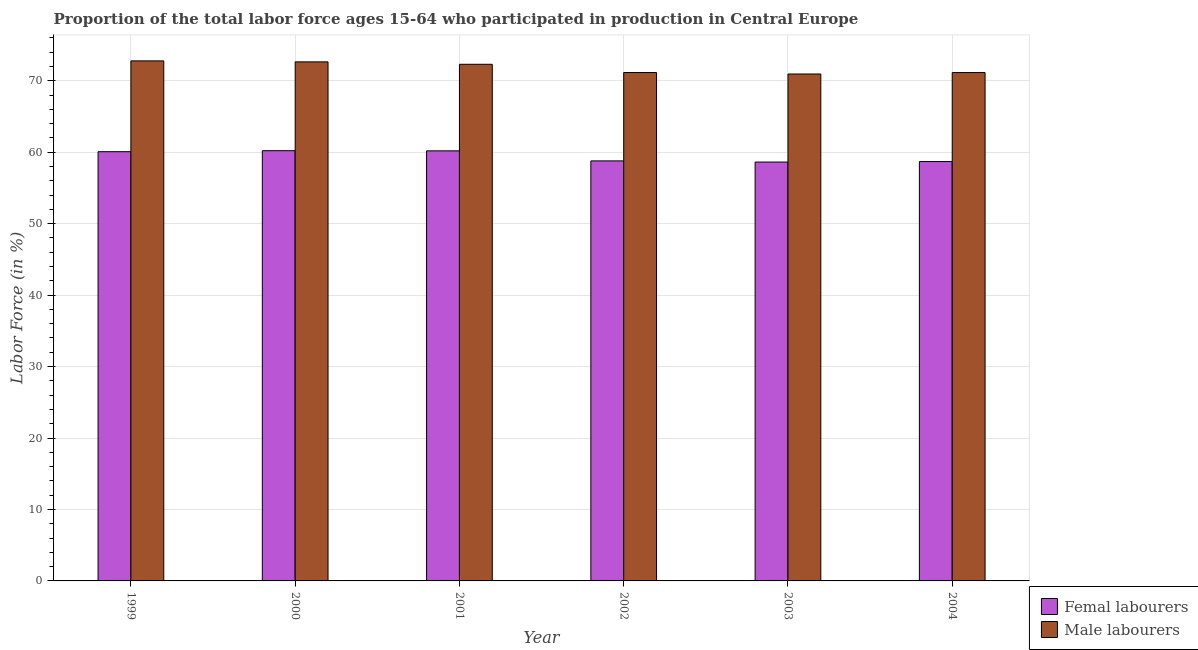Are the number of bars on each tick of the X-axis equal?
Your response must be concise. Yes. How many bars are there on the 3rd tick from the right?
Offer a very short reply. 2. What is the percentage of male labour force in 2001?
Offer a very short reply. 72.3. Across all years, what is the maximum percentage of male labour force?
Your answer should be compact. 72.78. Across all years, what is the minimum percentage of female labor force?
Your answer should be very brief. 58.62. In which year was the percentage of male labour force maximum?
Offer a terse response. 1999. What is the total percentage of male labour force in the graph?
Your response must be concise. 430.94. What is the difference between the percentage of female labor force in 1999 and that in 2001?
Your answer should be very brief. -0.12. What is the difference between the percentage of male labour force in 2000 and the percentage of female labor force in 1999?
Ensure brevity in your answer.  -0.14. What is the average percentage of female labor force per year?
Offer a very short reply. 59.43. What is the ratio of the percentage of male labour force in 2000 to that in 2001?
Your answer should be very brief. 1. Is the percentage of male labour force in 2003 less than that in 2004?
Ensure brevity in your answer.  Yes. Is the difference between the percentage of male labour force in 2001 and 2004 greater than the difference between the percentage of female labor force in 2001 and 2004?
Keep it short and to the point. No. What is the difference between the highest and the second highest percentage of male labour force?
Provide a short and direct response. 0.14. What is the difference between the highest and the lowest percentage of female labor force?
Your answer should be compact. 1.59. Is the sum of the percentage of female labor force in 1999 and 2001 greater than the maximum percentage of male labour force across all years?
Offer a very short reply. Yes. What does the 1st bar from the left in 2000 represents?
Keep it short and to the point. Femal labourers. What does the 1st bar from the right in 1999 represents?
Make the answer very short. Male labourers. How many bars are there?
Your answer should be very brief. 12. Are all the bars in the graph horizontal?
Offer a very short reply. No. Does the graph contain any zero values?
Make the answer very short. No. Does the graph contain grids?
Ensure brevity in your answer.  Yes. Where does the legend appear in the graph?
Offer a terse response. Bottom right. How many legend labels are there?
Offer a very short reply. 2. How are the legend labels stacked?
Your response must be concise. Vertical. What is the title of the graph?
Give a very brief answer. Proportion of the total labor force ages 15-64 who participated in production in Central Europe. What is the label or title of the X-axis?
Provide a short and direct response. Year. What is the label or title of the Y-axis?
Your answer should be compact. Labor Force (in %). What is the Labor Force (in %) in Femal labourers in 1999?
Your response must be concise. 60.07. What is the Labor Force (in %) in Male labourers in 1999?
Your response must be concise. 72.78. What is the Labor Force (in %) of Femal labourers in 2000?
Make the answer very short. 60.21. What is the Labor Force (in %) of Male labourers in 2000?
Make the answer very short. 72.64. What is the Labor Force (in %) in Femal labourers in 2001?
Provide a succinct answer. 60.19. What is the Labor Force (in %) in Male labourers in 2001?
Provide a succinct answer. 72.3. What is the Labor Force (in %) of Femal labourers in 2002?
Your response must be concise. 58.78. What is the Labor Force (in %) of Male labourers in 2002?
Your response must be concise. 71.15. What is the Labor Force (in %) in Femal labourers in 2003?
Give a very brief answer. 58.62. What is the Labor Force (in %) in Male labourers in 2003?
Offer a terse response. 70.94. What is the Labor Force (in %) of Femal labourers in 2004?
Make the answer very short. 58.69. What is the Labor Force (in %) of Male labourers in 2004?
Give a very brief answer. 71.14. Across all years, what is the maximum Labor Force (in %) of Femal labourers?
Your response must be concise. 60.21. Across all years, what is the maximum Labor Force (in %) in Male labourers?
Ensure brevity in your answer.  72.78. Across all years, what is the minimum Labor Force (in %) of Femal labourers?
Make the answer very short. 58.62. Across all years, what is the minimum Labor Force (in %) in Male labourers?
Offer a very short reply. 70.94. What is the total Labor Force (in %) of Femal labourers in the graph?
Give a very brief answer. 356.55. What is the total Labor Force (in %) of Male labourers in the graph?
Ensure brevity in your answer.  430.94. What is the difference between the Labor Force (in %) in Femal labourers in 1999 and that in 2000?
Offer a terse response. -0.14. What is the difference between the Labor Force (in %) in Male labourers in 1999 and that in 2000?
Provide a succinct answer. 0.14. What is the difference between the Labor Force (in %) of Femal labourers in 1999 and that in 2001?
Your answer should be compact. -0.12. What is the difference between the Labor Force (in %) in Male labourers in 1999 and that in 2001?
Your answer should be compact. 0.48. What is the difference between the Labor Force (in %) of Femal labourers in 1999 and that in 2002?
Ensure brevity in your answer.  1.29. What is the difference between the Labor Force (in %) in Male labourers in 1999 and that in 2002?
Give a very brief answer. 1.63. What is the difference between the Labor Force (in %) of Femal labourers in 1999 and that in 2003?
Ensure brevity in your answer.  1.45. What is the difference between the Labor Force (in %) of Male labourers in 1999 and that in 2003?
Your answer should be compact. 1.84. What is the difference between the Labor Force (in %) of Femal labourers in 1999 and that in 2004?
Your answer should be very brief. 1.38. What is the difference between the Labor Force (in %) in Male labourers in 1999 and that in 2004?
Make the answer very short. 1.64. What is the difference between the Labor Force (in %) of Femal labourers in 2000 and that in 2001?
Your answer should be compact. 0.02. What is the difference between the Labor Force (in %) in Male labourers in 2000 and that in 2001?
Ensure brevity in your answer.  0.34. What is the difference between the Labor Force (in %) of Femal labourers in 2000 and that in 2002?
Offer a terse response. 1.43. What is the difference between the Labor Force (in %) of Male labourers in 2000 and that in 2002?
Provide a short and direct response. 1.49. What is the difference between the Labor Force (in %) of Femal labourers in 2000 and that in 2003?
Your answer should be compact. 1.59. What is the difference between the Labor Force (in %) in Male labourers in 2000 and that in 2003?
Provide a succinct answer. 1.7. What is the difference between the Labor Force (in %) of Femal labourers in 2000 and that in 2004?
Make the answer very short. 1.52. What is the difference between the Labor Force (in %) of Male labourers in 2000 and that in 2004?
Ensure brevity in your answer.  1.5. What is the difference between the Labor Force (in %) of Femal labourers in 2001 and that in 2002?
Offer a very short reply. 1.41. What is the difference between the Labor Force (in %) in Male labourers in 2001 and that in 2002?
Your response must be concise. 1.16. What is the difference between the Labor Force (in %) of Femal labourers in 2001 and that in 2003?
Provide a succinct answer. 1.57. What is the difference between the Labor Force (in %) in Male labourers in 2001 and that in 2003?
Your answer should be compact. 1.36. What is the difference between the Labor Force (in %) of Femal labourers in 2001 and that in 2004?
Make the answer very short. 1.5. What is the difference between the Labor Force (in %) in Male labourers in 2001 and that in 2004?
Give a very brief answer. 1.16. What is the difference between the Labor Force (in %) in Femal labourers in 2002 and that in 2003?
Give a very brief answer. 0.16. What is the difference between the Labor Force (in %) in Male labourers in 2002 and that in 2003?
Offer a very short reply. 0.2. What is the difference between the Labor Force (in %) of Femal labourers in 2002 and that in 2004?
Ensure brevity in your answer.  0.09. What is the difference between the Labor Force (in %) in Male labourers in 2002 and that in 2004?
Offer a very short reply. 0. What is the difference between the Labor Force (in %) of Femal labourers in 2003 and that in 2004?
Keep it short and to the point. -0.07. What is the difference between the Labor Force (in %) of Male labourers in 2003 and that in 2004?
Your answer should be very brief. -0.2. What is the difference between the Labor Force (in %) of Femal labourers in 1999 and the Labor Force (in %) of Male labourers in 2000?
Provide a short and direct response. -12.57. What is the difference between the Labor Force (in %) of Femal labourers in 1999 and the Labor Force (in %) of Male labourers in 2001?
Provide a short and direct response. -12.23. What is the difference between the Labor Force (in %) in Femal labourers in 1999 and the Labor Force (in %) in Male labourers in 2002?
Your answer should be compact. -11.08. What is the difference between the Labor Force (in %) of Femal labourers in 1999 and the Labor Force (in %) of Male labourers in 2003?
Ensure brevity in your answer.  -10.87. What is the difference between the Labor Force (in %) of Femal labourers in 1999 and the Labor Force (in %) of Male labourers in 2004?
Your response must be concise. -11.07. What is the difference between the Labor Force (in %) of Femal labourers in 2000 and the Labor Force (in %) of Male labourers in 2001?
Provide a succinct answer. -12.09. What is the difference between the Labor Force (in %) of Femal labourers in 2000 and the Labor Force (in %) of Male labourers in 2002?
Provide a succinct answer. -10.94. What is the difference between the Labor Force (in %) in Femal labourers in 2000 and the Labor Force (in %) in Male labourers in 2003?
Provide a short and direct response. -10.73. What is the difference between the Labor Force (in %) in Femal labourers in 2000 and the Labor Force (in %) in Male labourers in 2004?
Make the answer very short. -10.93. What is the difference between the Labor Force (in %) in Femal labourers in 2001 and the Labor Force (in %) in Male labourers in 2002?
Your answer should be very brief. -10.96. What is the difference between the Labor Force (in %) in Femal labourers in 2001 and the Labor Force (in %) in Male labourers in 2003?
Your response must be concise. -10.75. What is the difference between the Labor Force (in %) of Femal labourers in 2001 and the Labor Force (in %) of Male labourers in 2004?
Keep it short and to the point. -10.95. What is the difference between the Labor Force (in %) in Femal labourers in 2002 and the Labor Force (in %) in Male labourers in 2003?
Your answer should be very brief. -12.16. What is the difference between the Labor Force (in %) of Femal labourers in 2002 and the Labor Force (in %) of Male labourers in 2004?
Provide a short and direct response. -12.36. What is the difference between the Labor Force (in %) in Femal labourers in 2003 and the Labor Force (in %) in Male labourers in 2004?
Offer a very short reply. -12.52. What is the average Labor Force (in %) of Femal labourers per year?
Give a very brief answer. 59.42. What is the average Labor Force (in %) of Male labourers per year?
Offer a terse response. 71.82. In the year 1999, what is the difference between the Labor Force (in %) of Femal labourers and Labor Force (in %) of Male labourers?
Your response must be concise. -12.71. In the year 2000, what is the difference between the Labor Force (in %) in Femal labourers and Labor Force (in %) in Male labourers?
Offer a very short reply. -12.43. In the year 2001, what is the difference between the Labor Force (in %) of Femal labourers and Labor Force (in %) of Male labourers?
Offer a terse response. -12.11. In the year 2002, what is the difference between the Labor Force (in %) of Femal labourers and Labor Force (in %) of Male labourers?
Offer a very short reply. -12.37. In the year 2003, what is the difference between the Labor Force (in %) of Femal labourers and Labor Force (in %) of Male labourers?
Offer a very short reply. -12.32. In the year 2004, what is the difference between the Labor Force (in %) of Femal labourers and Labor Force (in %) of Male labourers?
Offer a terse response. -12.45. What is the ratio of the Labor Force (in %) of Femal labourers in 1999 to that in 2000?
Keep it short and to the point. 1. What is the ratio of the Labor Force (in %) in Male labourers in 1999 to that in 2000?
Your response must be concise. 1. What is the ratio of the Labor Force (in %) of Male labourers in 1999 to that in 2001?
Provide a short and direct response. 1.01. What is the ratio of the Labor Force (in %) of Femal labourers in 1999 to that in 2002?
Give a very brief answer. 1.02. What is the ratio of the Labor Force (in %) of Male labourers in 1999 to that in 2002?
Offer a very short reply. 1.02. What is the ratio of the Labor Force (in %) in Femal labourers in 1999 to that in 2003?
Offer a very short reply. 1.02. What is the ratio of the Labor Force (in %) of Male labourers in 1999 to that in 2003?
Give a very brief answer. 1.03. What is the ratio of the Labor Force (in %) in Femal labourers in 1999 to that in 2004?
Keep it short and to the point. 1.02. What is the ratio of the Labor Force (in %) of Male labourers in 1999 to that in 2004?
Provide a short and direct response. 1.02. What is the ratio of the Labor Force (in %) in Male labourers in 2000 to that in 2001?
Your response must be concise. 1. What is the ratio of the Labor Force (in %) of Femal labourers in 2000 to that in 2002?
Your answer should be compact. 1.02. What is the ratio of the Labor Force (in %) of Male labourers in 2000 to that in 2002?
Keep it short and to the point. 1.02. What is the ratio of the Labor Force (in %) of Femal labourers in 2000 to that in 2003?
Provide a succinct answer. 1.03. What is the ratio of the Labor Force (in %) in Male labourers in 2000 to that in 2003?
Ensure brevity in your answer.  1.02. What is the ratio of the Labor Force (in %) of Femal labourers in 2000 to that in 2004?
Offer a terse response. 1.03. What is the ratio of the Labor Force (in %) of Male labourers in 2000 to that in 2004?
Keep it short and to the point. 1.02. What is the ratio of the Labor Force (in %) in Femal labourers in 2001 to that in 2002?
Provide a short and direct response. 1.02. What is the ratio of the Labor Force (in %) in Male labourers in 2001 to that in 2002?
Provide a short and direct response. 1.02. What is the ratio of the Labor Force (in %) of Femal labourers in 2001 to that in 2003?
Make the answer very short. 1.03. What is the ratio of the Labor Force (in %) of Male labourers in 2001 to that in 2003?
Ensure brevity in your answer.  1.02. What is the ratio of the Labor Force (in %) of Femal labourers in 2001 to that in 2004?
Make the answer very short. 1.03. What is the ratio of the Labor Force (in %) of Male labourers in 2001 to that in 2004?
Provide a succinct answer. 1.02. What is the ratio of the Labor Force (in %) in Femal labourers in 2002 to that in 2003?
Your answer should be very brief. 1. What is the ratio of the Labor Force (in %) of Male labourers in 2002 to that in 2003?
Provide a succinct answer. 1. What is the ratio of the Labor Force (in %) in Femal labourers in 2002 to that in 2004?
Give a very brief answer. 1. What is the ratio of the Labor Force (in %) in Male labourers in 2002 to that in 2004?
Offer a terse response. 1. What is the ratio of the Labor Force (in %) of Male labourers in 2003 to that in 2004?
Your answer should be very brief. 1. What is the difference between the highest and the second highest Labor Force (in %) of Femal labourers?
Your answer should be very brief. 0.02. What is the difference between the highest and the second highest Labor Force (in %) in Male labourers?
Make the answer very short. 0.14. What is the difference between the highest and the lowest Labor Force (in %) of Femal labourers?
Keep it short and to the point. 1.59. What is the difference between the highest and the lowest Labor Force (in %) of Male labourers?
Your response must be concise. 1.84. 